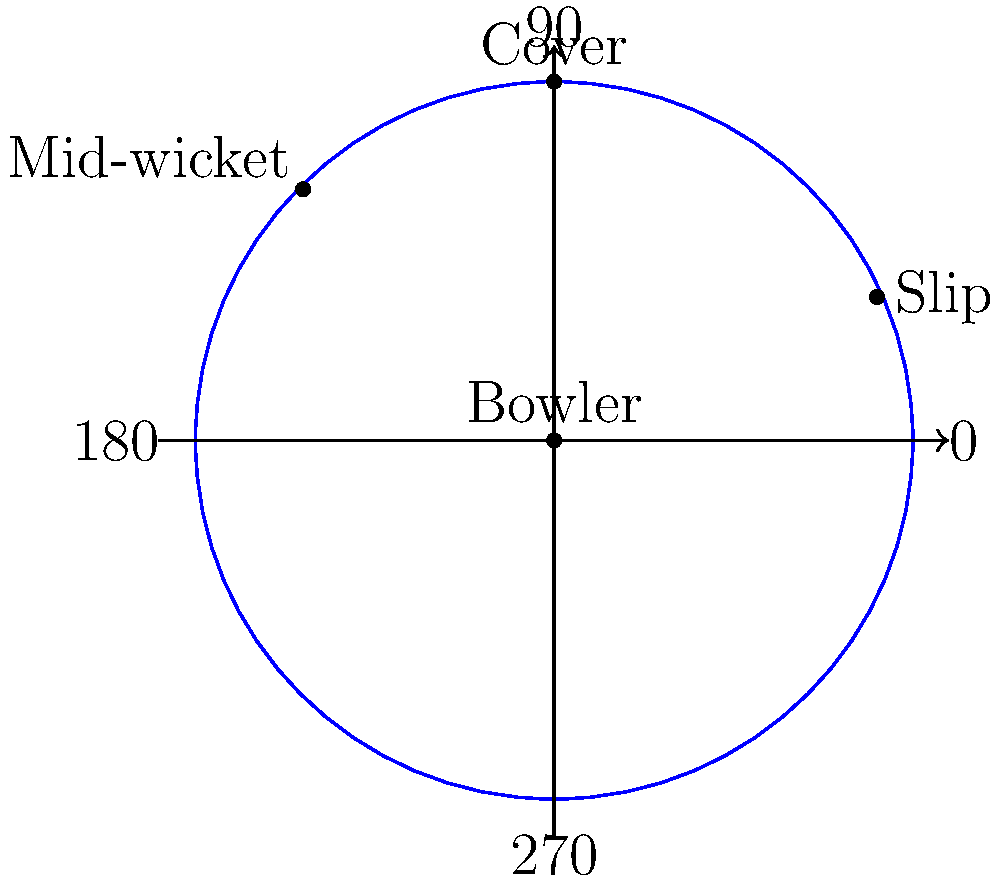In a cricket match, you're the captain positioning your fielders. Using the polar coordinate system with the bowler at the origin, the slip fielder is placed at a radius of 2 units and an angle of 25°. What would be the approximate angle (in degrees) for the mid-wicket fielder if they are placed at the same radius? To solve this problem, let's follow these steps:

1) First, recall that in polar coordinates, we measure angles counterclockwise from the positive x-axis.

2) The slip fielder is typically positioned behind the batsman, which corresponds to the first quadrant in our polar coordinate system. This matches the given angle of 25°.

3) The mid-wicket fielder is usually positioned on the leg side (left side for a right-handed batsman), which would be in the second quadrant of our polar coordinate system.

4) Looking at the diagram, we can see that the mid-wicket fielder is positioned roughly halfway between 90° and 180°.

5) The exact midpoint between 90° and 180° would be:
   $$(90° + 180°) \div 2 = 135°$$

6) From the diagram, the mid-wicket fielder appears to be slightly closer to 135° than to either 90° or 180°.

7) A reasonable estimate for the mid-wicket fielder's position would therefore be around 135°.
Answer: 135° 